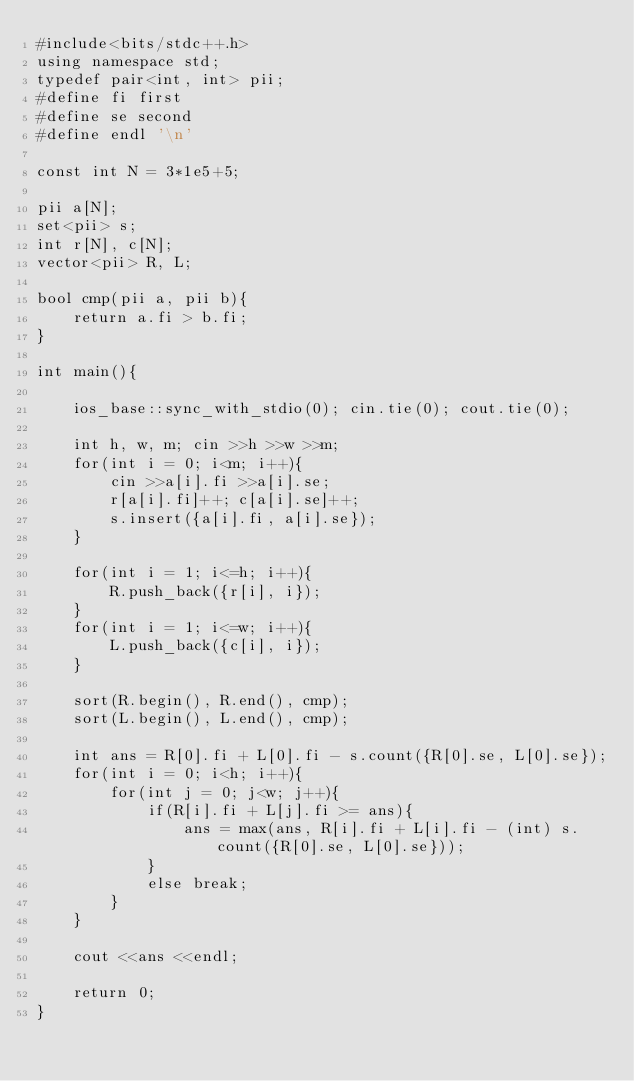<code> <loc_0><loc_0><loc_500><loc_500><_C++_>#include<bits/stdc++.h>
using namespace std;
typedef pair<int, int> pii;
#define fi first
#define se second
#define endl '\n'

const int N = 3*1e5+5;

pii a[N];
set<pii> s;
int r[N], c[N];
vector<pii> R, L;

bool cmp(pii a, pii b){
    return a.fi > b.fi;
}

int main(){

    ios_base::sync_with_stdio(0); cin.tie(0); cout.tie(0);

    int h, w, m; cin >>h >>w >>m;
    for(int i = 0; i<m; i++){
        cin >>a[i].fi >>a[i].se;
        r[a[i].fi]++; c[a[i].se]++;
        s.insert({a[i].fi, a[i].se});
    }

    for(int i = 1; i<=h; i++){
        R.push_back({r[i], i});
    }
    for(int i = 1; i<=w; i++){
        L.push_back({c[i], i});
    }

    sort(R.begin(), R.end(), cmp);
    sort(L.begin(), L.end(), cmp);

    int ans = R[0].fi + L[0].fi - s.count({R[0].se, L[0].se});
    for(int i = 0; i<h; i++){
        for(int j = 0; j<w; j++){
            if(R[i].fi + L[j].fi >= ans){
                ans = max(ans, R[i].fi + L[i].fi - (int) s.count({R[0].se, L[0].se}));
            }
            else break;
        }
    }

    cout <<ans <<endl;

    return 0;
}
</code> 